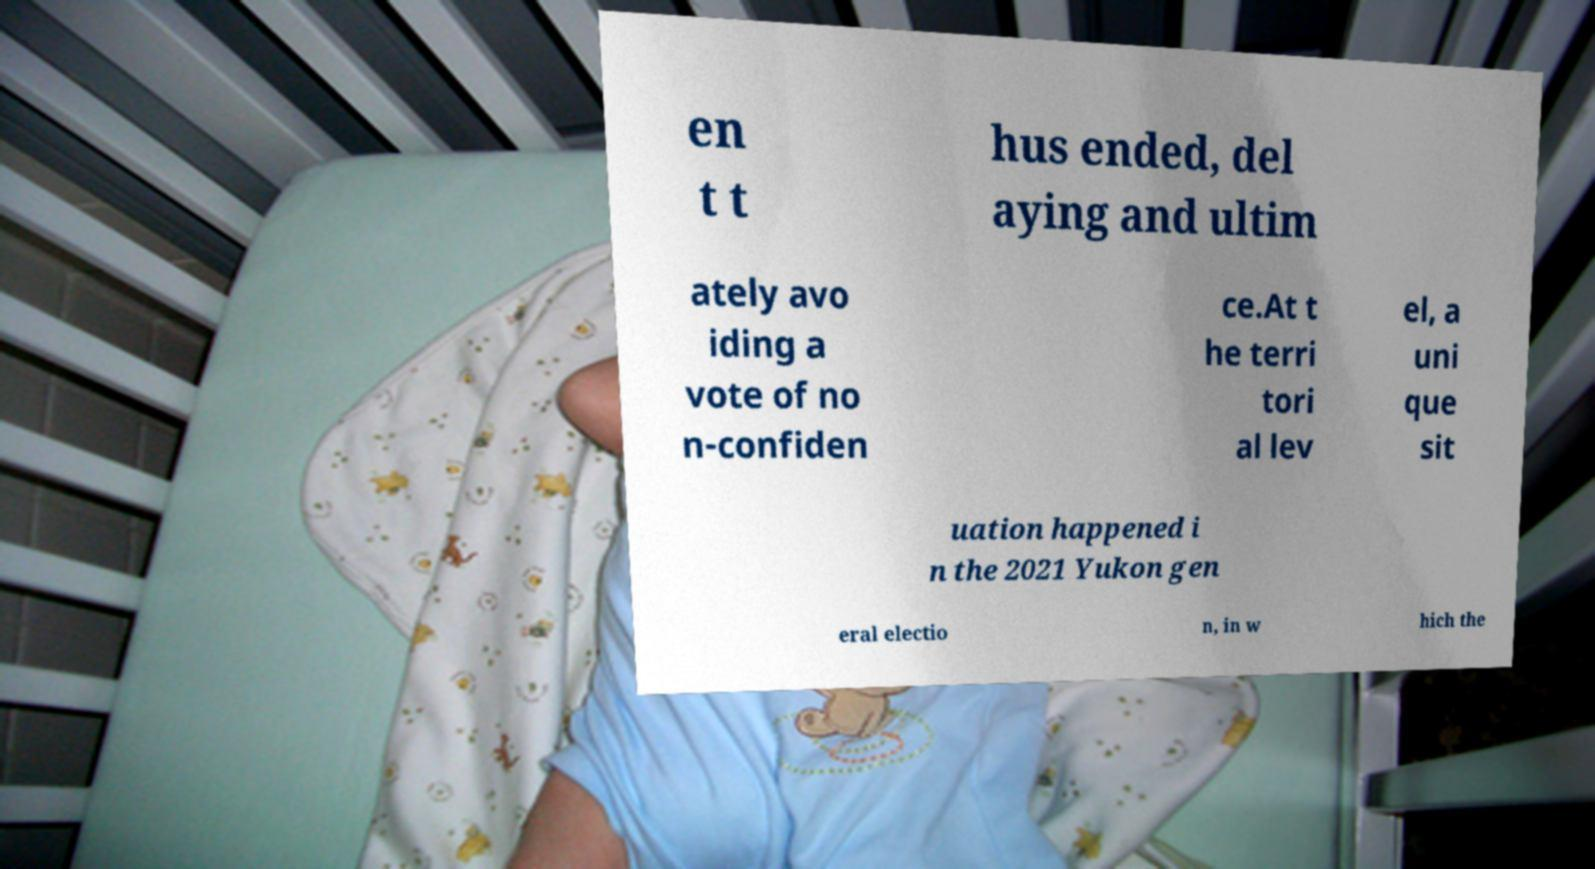Could you assist in decoding the text presented in this image and type it out clearly? en t t hus ended, del aying and ultim ately avo iding a vote of no n-confiden ce.At t he terri tori al lev el, a uni que sit uation happened i n the 2021 Yukon gen eral electio n, in w hich the 